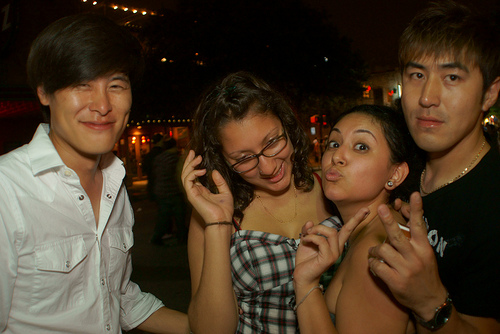<image>
Can you confirm if the glasses is on the girl? No. The glasses is not positioned on the girl. They may be near each other, but the glasses is not supported by or resting on top of the girl. Where is the lights in relation to the door? Is it in front of the door? Yes. The lights is positioned in front of the door, appearing closer to the camera viewpoint. 